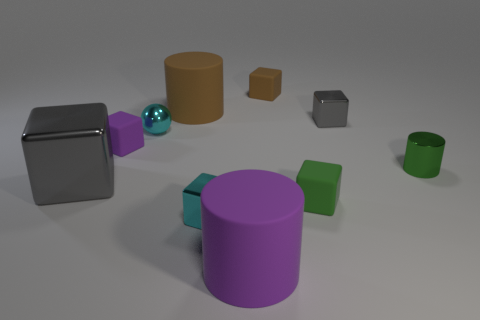Subtract all large gray blocks. How many blocks are left? 5 Subtract all yellow cylinders. How many gray cubes are left? 2 Subtract all brown cubes. How many cubes are left? 5 Subtract 1 blocks. How many blocks are left? 5 Subtract all blocks. How many objects are left? 4 Subtract 1 cyan spheres. How many objects are left? 9 Subtract all red cubes. Subtract all purple cylinders. How many cubes are left? 6 Subtract all large gray cubes. Subtract all large purple rubber cylinders. How many objects are left? 8 Add 4 metal cubes. How many metal cubes are left? 7 Add 9 small green blocks. How many small green blocks exist? 10 